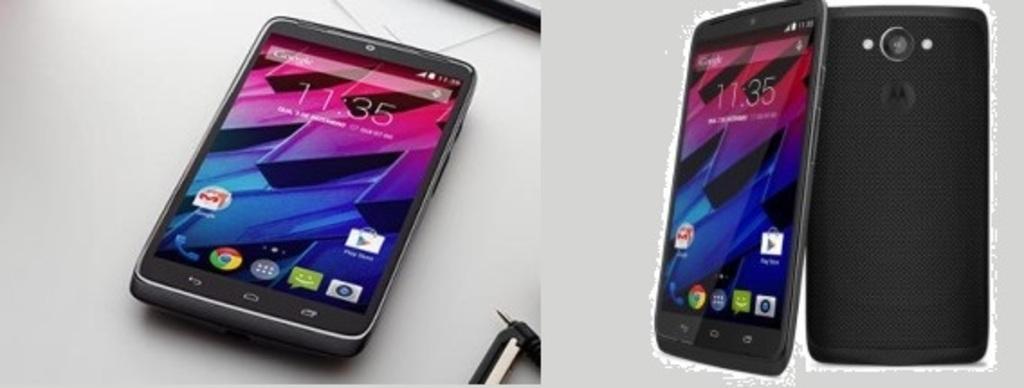Can you describe this image briefly? This is an edited image and we can see the mobile phones and we can see the text, numbers and the icons on the display of the mobile phones. In the background we can see a table and some other objects. 